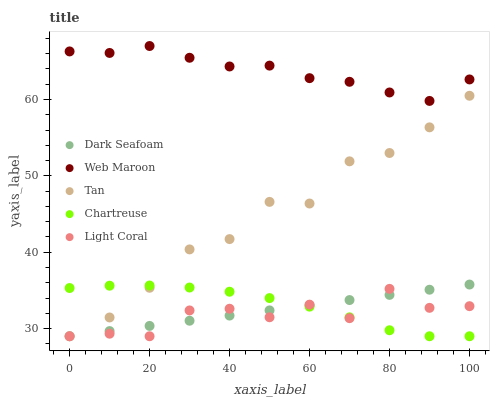Does Light Coral have the minimum area under the curve?
Answer yes or no. Yes. Does Web Maroon have the maximum area under the curve?
Answer yes or no. Yes. Does Dark Seafoam have the minimum area under the curve?
Answer yes or no. No. Does Dark Seafoam have the maximum area under the curve?
Answer yes or no. No. Is Dark Seafoam the smoothest?
Answer yes or no. Yes. Is Light Coral the roughest?
Answer yes or no. Yes. Is Web Maroon the smoothest?
Answer yes or no. No. Is Web Maroon the roughest?
Answer yes or no. No. Does Light Coral have the lowest value?
Answer yes or no. Yes. Does Web Maroon have the lowest value?
Answer yes or no. No. Does Web Maroon have the highest value?
Answer yes or no. Yes. Does Dark Seafoam have the highest value?
Answer yes or no. No. Is Dark Seafoam less than Web Maroon?
Answer yes or no. Yes. Is Web Maroon greater than Tan?
Answer yes or no. Yes. Does Light Coral intersect Dark Seafoam?
Answer yes or no. Yes. Is Light Coral less than Dark Seafoam?
Answer yes or no. No. Is Light Coral greater than Dark Seafoam?
Answer yes or no. No. Does Dark Seafoam intersect Web Maroon?
Answer yes or no. No. 